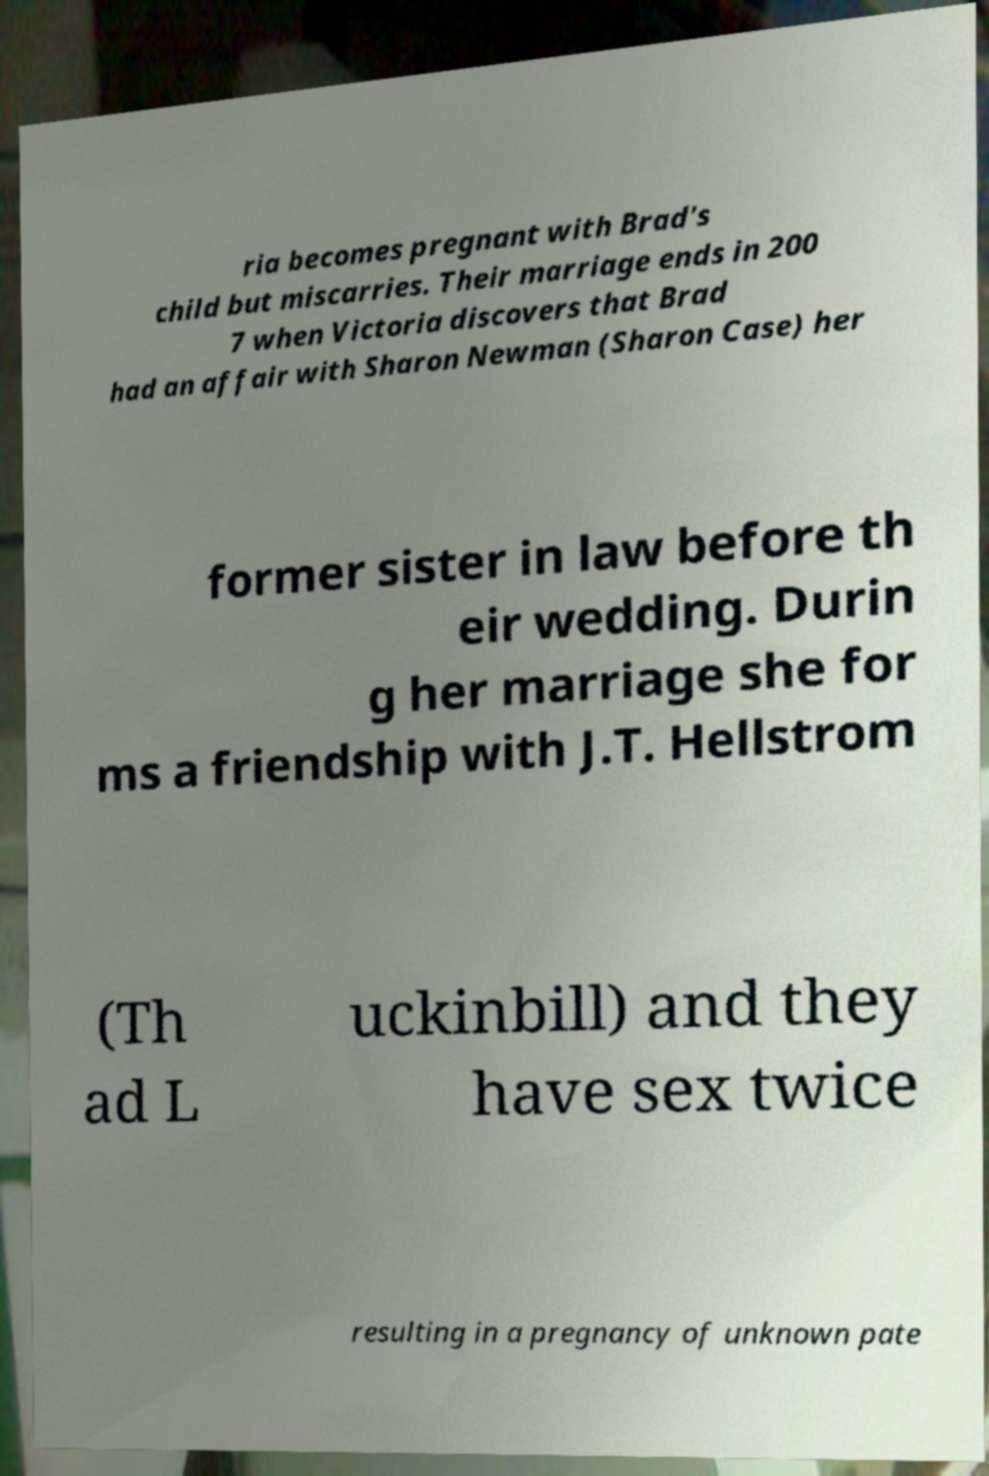Please read and relay the text visible in this image. What does it say? ria becomes pregnant with Brad's child but miscarries. Their marriage ends in 200 7 when Victoria discovers that Brad had an affair with Sharon Newman (Sharon Case) her former sister in law before th eir wedding. Durin g her marriage she for ms a friendship with J.T. Hellstrom (Th ad L uckinbill) and they have sex twice resulting in a pregnancy of unknown pate 